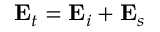Convert formula to latex. <formula><loc_0><loc_0><loc_500><loc_500>E _ { t } = E _ { i } + E _ { s }</formula> 